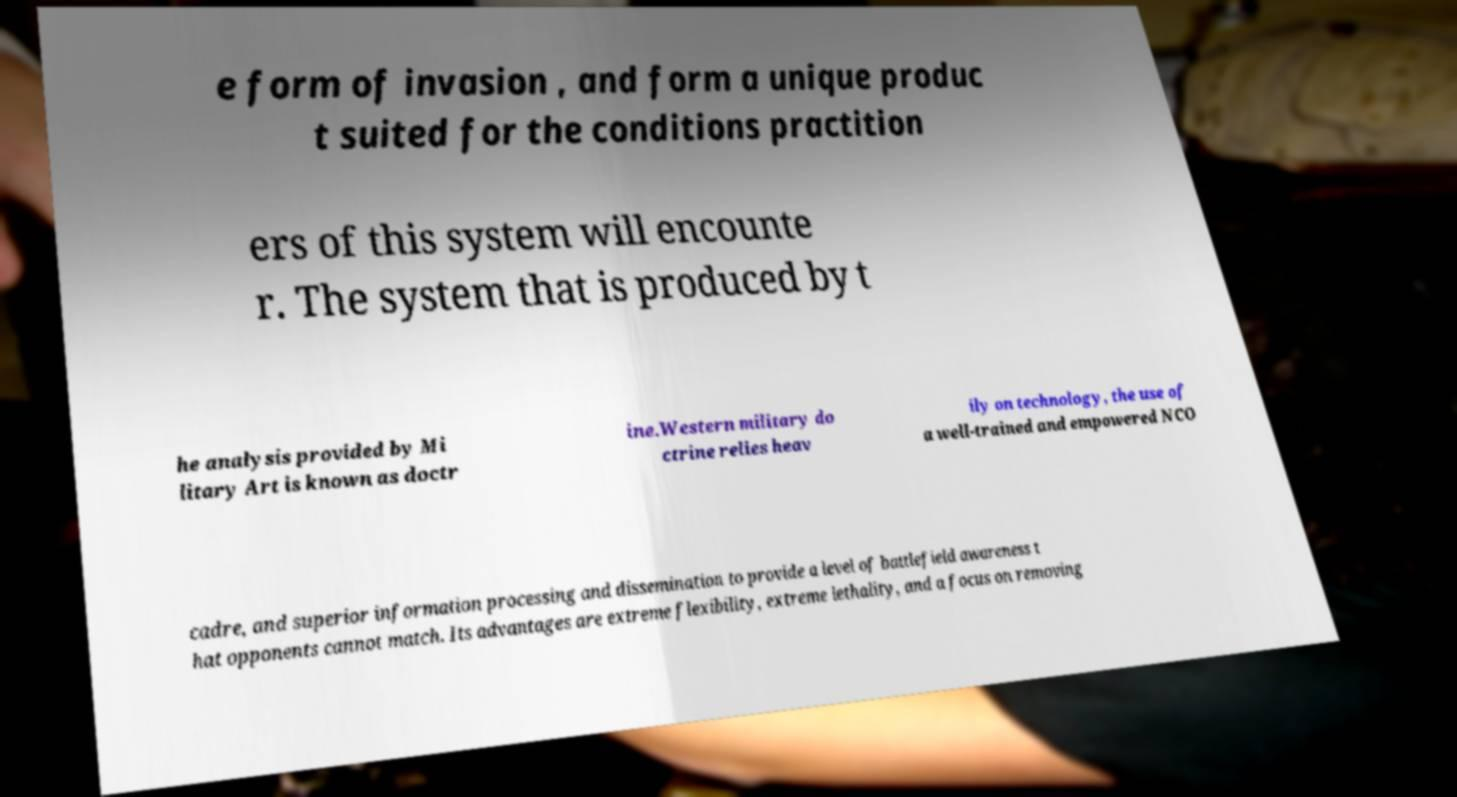There's text embedded in this image that I need extracted. Can you transcribe it verbatim? e form of invasion , and form a unique produc t suited for the conditions practition ers of this system will encounte r. The system that is produced by t he analysis provided by Mi litary Art is known as doctr ine.Western military do ctrine relies heav ily on technology, the use of a well-trained and empowered NCO cadre, and superior information processing and dissemination to provide a level of battlefield awareness t hat opponents cannot match. Its advantages are extreme flexibility, extreme lethality, and a focus on removing 